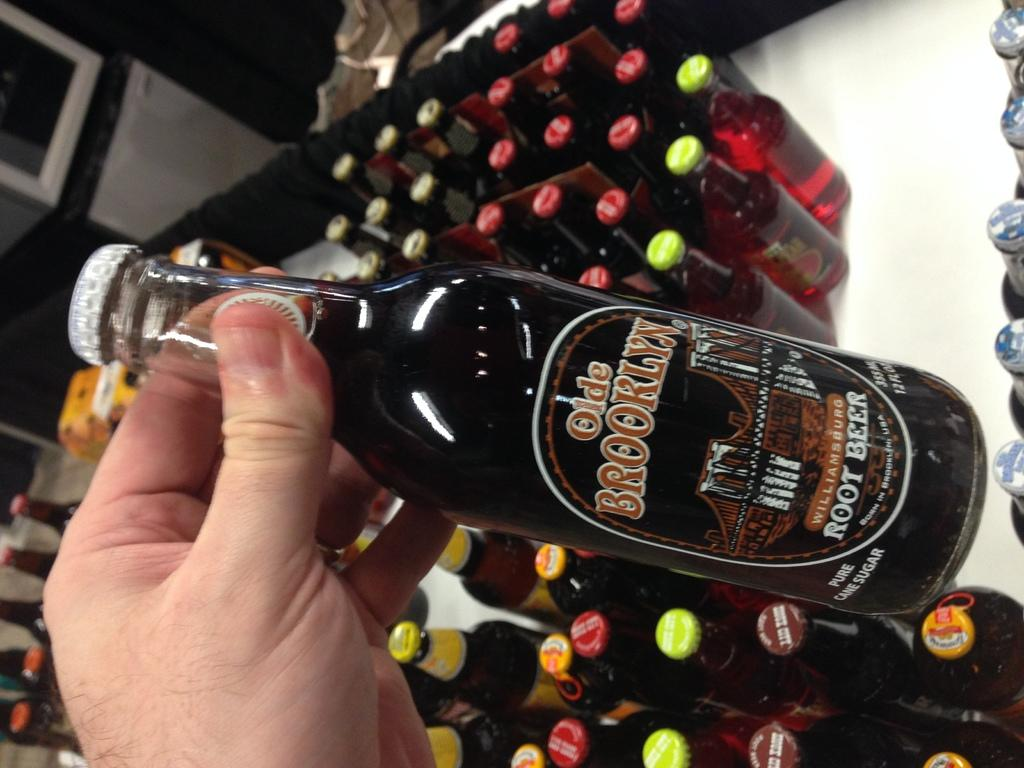<image>
Present a compact description of the photo's key features. A clear bottle of root beer called olde brooklyn. 